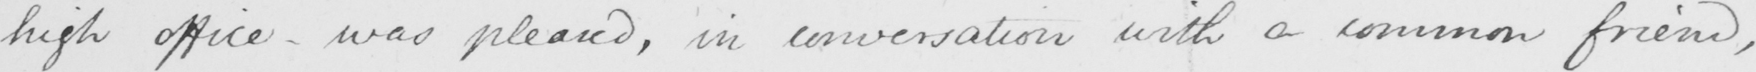Please transcribe the handwritten text in this image. high office  _  was pleased , in conversation with a common friend , 